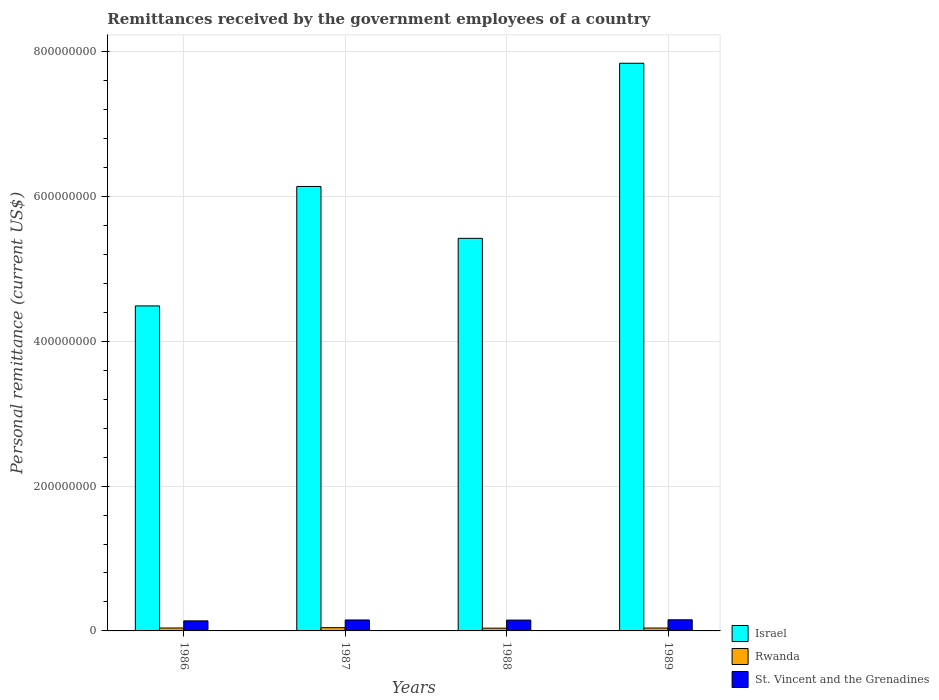Are the number of bars per tick equal to the number of legend labels?
Provide a succinct answer. Yes. Are the number of bars on each tick of the X-axis equal?
Your answer should be very brief. Yes. How many bars are there on the 1st tick from the right?
Keep it short and to the point. 3. What is the remittances received by the government employees in Israel in 1987?
Give a very brief answer. 6.14e+08. Across all years, what is the maximum remittances received by the government employees in St. Vincent and the Grenadines?
Keep it short and to the point. 1.54e+07. Across all years, what is the minimum remittances received by the government employees in St. Vincent and the Grenadines?
Make the answer very short. 1.39e+07. What is the total remittances received by the government employees in Rwanda in the graph?
Make the answer very short. 1.63e+07. What is the difference between the remittances received by the government employees in Rwanda in 1987 and that in 1989?
Keep it short and to the point. 5.25e+05. What is the difference between the remittances received by the government employees in Rwanda in 1988 and the remittances received by the government employees in St. Vincent and the Grenadines in 1987?
Offer a very short reply. -1.13e+07. What is the average remittances received by the government employees in Rwanda per year?
Provide a short and direct response. 4.07e+06. In the year 1989, what is the difference between the remittances received by the government employees in St. Vincent and the Grenadines and remittances received by the government employees in Israel?
Provide a succinct answer. -7.68e+08. What is the ratio of the remittances received by the government employees in Rwanda in 1988 to that in 1989?
Keep it short and to the point. 0.96. Is the difference between the remittances received by the government employees in St. Vincent and the Grenadines in 1987 and 1988 greater than the difference between the remittances received by the government employees in Israel in 1987 and 1988?
Offer a very short reply. No. What is the difference between the highest and the second highest remittances received by the government employees in St. Vincent and the Grenadines?
Give a very brief answer. 2.59e+05. What is the difference between the highest and the lowest remittances received by the government employees in Israel?
Give a very brief answer. 3.35e+08. What does the 2nd bar from the left in 1988 represents?
Offer a terse response. Rwanda. What does the 2nd bar from the right in 1989 represents?
Your answer should be very brief. Rwanda. How many bars are there?
Provide a short and direct response. 12. How many years are there in the graph?
Keep it short and to the point. 4. Does the graph contain any zero values?
Your response must be concise. No. Where does the legend appear in the graph?
Your answer should be very brief. Bottom right. How many legend labels are there?
Your response must be concise. 3. How are the legend labels stacked?
Ensure brevity in your answer.  Vertical. What is the title of the graph?
Provide a short and direct response. Remittances received by the government employees of a country. What is the label or title of the X-axis?
Ensure brevity in your answer.  Years. What is the label or title of the Y-axis?
Offer a very short reply. Personal remittance (current US$). What is the Personal remittance (current US$) in Israel in 1986?
Keep it short and to the point. 4.49e+08. What is the Personal remittance (current US$) in Rwanda in 1986?
Offer a very short reply. 4.02e+06. What is the Personal remittance (current US$) in St. Vincent and the Grenadines in 1986?
Give a very brief answer. 1.39e+07. What is the Personal remittance (current US$) in Israel in 1987?
Offer a very short reply. 6.14e+08. What is the Personal remittance (current US$) in Rwanda in 1987?
Give a very brief answer. 4.48e+06. What is the Personal remittance (current US$) of St. Vincent and the Grenadines in 1987?
Make the answer very short. 1.51e+07. What is the Personal remittance (current US$) in Israel in 1988?
Keep it short and to the point. 5.42e+08. What is the Personal remittance (current US$) in Rwanda in 1988?
Your answer should be very brief. 3.81e+06. What is the Personal remittance (current US$) of St. Vincent and the Grenadines in 1988?
Give a very brief answer. 1.50e+07. What is the Personal remittance (current US$) in Israel in 1989?
Provide a succinct answer. 7.84e+08. What is the Personal remittance (current US$) in Rwanda in 1989?
Keep it short and to the point. 3.96e+06. What is the Personal remittance (current US$) in St. Vincent and the Grenadines in 1989?
Give a very brief answer. 1.54e+07. Across all years, what is the maximum Personal remittance (current US$) of Israel?
Make the answer very short. 7.84e+08. Across all years, what is the maximum Personal remittance (current US$) in Rwanda?
Your answer should be very brief. 4.48e+06. Across all years, what is the maximum Personal remittance (current US$) of St. Vincent and the Grenadines?
Make the answer very short. 1.54e+07. Across all years, what is the minimum Personal remittance (current US$) of Israel?
Your response must be concise. 4.49e+08. Across all years, what is the minimum Personal remittance (current US$) of Rwanda?
Your answer should be compact. 3.81e+06. Across all years, what is the minimum Personal remittance (current US$) of St. Vincent and the Grenadines?
Your answer should be very brief. 1.39e+07. What is the total Personal remittance (current US$) of Israel in the graph?
Make the answer very short. 2.39e+09. What is the total Personal remittance (current US$) of Rwanda in the graph?
Make the answer very short. 1.63e+07. What is the total Personal remittance (current US$) of St. Vincent and the Grenadines in the graph?
Ensure brevity in your answer.  5.93e+07. What is the difference between the Personal remittance (current US$) of Israel in 1986 and that in 1987?
Give a very brief answer. -1.65e+08. What is the difference between the Personal remittance (current US$) in Rwanda in 1986 and that in 1987?
Give a very brief answer. -4.62e+05. What is the difference between the Personal remittance (current US$) of St. Vincent and the Grenadines in 1986 and that in 1987?
Provide a succinct answer. -1.22e+06. What is the difference between the Personal remittance (current US$) in Israel in 1986 and that in 1988?
Give a very brief answer. -9.33e+07. What is the difference between the Personal remittance (current US$) in Rwanda in 1986 and that in 1988?
Offer a terse response. 2.12e+05. What is the difference between the Personal remittance (current US$) in St. Vincent and the Grenadines in 1986 and that in 1988?
Your answer should be compact. -1.07e+06. What is the difference between the Personal remittance (current US$) of Israel in 1986 and that in 1989?
Make the answer very short. -3.35e+08. What is the difference between the Personal remittance (current US$) of Rwanda in 1986 and that in 1989?
Make the answer very short. 6.35e+04. What is the difference between the Personal remittance (current US$) of St. Vincent and the Grenadines in 1986 and that in 1989?
Offer a very short reply. -1.48e+06. What is the difference between the Personal remittance (current US$) of Israel in 1987 and that in 1988?
Keep it short and to the point. 7.16e+07. What is the difference between the Personal remittance (current US$) of Rwanda in 1987 and that in 1988?
Offer a very short reply. 6.74e+05. What is the difference between the Personal remittance (current US$) of St. Vincent and the Grenadines in 1987 and that in 1988?
Your answer should be very brief. 1.48e+05. What is the difference between the Personal remittance (current US$) of Israel in 1987 and that in 1989?
Make the answer very short. -1.70e+08. What is the difference between the Personal remittance (current US$) in Rwanda in 1987 and that in 1989?
Provide a short and direct response. 5.25e+05. What is the difference between the Personal remittance (current US$) of St. Vincent and the Grenadines in 1987 and that in 1989?
Ensure brevity in your answer.  -2.59e+05. What is the difference between the Personal remittance (current US$) in Israel in 1988 and that in 1989?
Your response must be concise. -2.42e+08. What is the difference between the Personal remittance (current US$) in Rwanda in 1988 and that in 1989?
Your response must be concise. -1.49e+05. What is the difference between the Personal remittance (current US$) of St. Vincent and the Grenadines in 1988 and that in 1989?
Provide a short and direct response. -4.07e+05. What is the difference between the Personal remittance (current US$) in Israel in 1986 and the Personal remittance (current US$) in Rwanda in 1987?
Provide a succinct answer. 4.44e+08. What is the difference between the Personal remittance (current US$) of Israel in 1986 and the Personal remittance (current US$) of St. Vincent and the Grenadines in 1987?
Make the answer very short. 4.34e+08. What is the difference between the Personal remittance (current US$) in Rwanda in 1986 and the Personal remittance (current US$) in St. Vincent and the Grenadines in 1987?
Provide a short and direct response. -1.11e+07. What is the difference between the Personal remittance (current US$) of Israel in 1986 and the Personal remittance (current US$) of Rwanda in 1988?
Provide a succinct answer. 4.45e+08. What is the difference between the Personal remittance (current US$) of Israel in 1986 and the Personal remittance (current US$) of St. Vincent and the Grenadines in 1988?
Provide a succinct answer. 4.34e+08. What is the difference between the Personal remittance (current US$) in Rwanda in 1986 and the Personal remittance (current US$) in St. Vincent and the Grenadines in 1988?
Offer a terse response. -1.09e+07. What is the difference between the Personal remittance (current US$) in Israel in 1986 and the Personal remittance (current US$) in Rwanda in 1989?
Your answer should be very brief. 4.45e+08. What is the difference between the Personal remittance (current US$) of Israel in 1986 and the Personal remittance (current US$) of St. Vincent and the Grenadines in 1989?
Make the answer very short. 4.33e+08. What is the difference between the Personal remittance (current US$) of Rwanda in 1986 and the Personal remittance (current US$) of St. Vincent and the Grenadines in 1989?
Provide a succinct answer. -1.14e+07. What is the difference between the Personal remittance (current US$) in Israel in 1987 and the Personal remittance (current US$) in Rwanda in 1988?
Your answer should be compact. 6.10e+08. What is the difference between the Personal remittance (current US$) of Israel in 1987 and the Personal remittance (current US$) of St. Vincent and the Grenadines in 1988?
Ensure brevity in your answer.  5.99e+08. What is the difference between the Personal remittance (current US$) in Rwanda in 1987 and the Personal remittance (current US$) in St. Vincent and the Grenadines in 1988?
Your response must be concise. -1.05e+07. What is the difference between the Personal remittance (current US$) in Israel in 1987 and the Personal remittance (current US$) in Rwanda in 1989?
Make the answer very short. 6.10e+08. What is the difference between the Personal remittance (current US$) in Israel in 1987 and the Personal remittance (current US$) in St. Vincent and the Grenadines in 1989?
Your answer should be compact. 5.98e+08. What is the difference between the Personal remittance (current US$) of Rwanda in 1987 and the Personal remittance (current US$) of St. Vincent and the Grenadines in 1989?
Keep it short and to the point. -1.09e+07. What is the difference between the Personal remittance (current US$) of Israel in 1988 and the Personal remittance (current US$) of Rwanda in 1989?
Keep it short and to the point. 5.38e+08. What is the difference between the Personal remittance (current US$) of Israel in 1988 and the Personal remittance (current US$) of St. Vincent and the Grenadines in 1989?
Offer a very short reply. 5.27e+08. What is the difference between the Personal remittance (current US$) in Rwanda in 1988 and the Personal remittance (current US$) in St. Vincent and the Grenadines in 1989?
Provide a short and direct response. -1.16e+07. What is the average Personal remittance (current US$) of Israel per year?
Provide a succinct answer. 5.97e+08. What is the average Personal remittance (current US$) of Rwanda per year?
Provide a short and direct response. 4.07e+06. What is the average Personal remittance (current US$) of St. Vincent and the Grenadines per year?
Your answer should be compact. 1.48e+07. In the year 1986, what is the difference between the Personal remittance (current US$) in Israel and Personal remittance (current US$) in Rwanda?
Your response must be concise. 4.45e+08. In the year 1986, what is the difference between the Personal remittance (current US$) in Israel and Personal remittance (current US$) in St. Vincent and the Grenadines?
Your answer should be very brief. 4.35e+08. In the year 1986, what is the difference between the Personal remittance (current US$) of Rwanda and Personal remittance (current US$) of St. Vincent and the Grenadines?
Offer a very short reply. -9.87e+06. In the year 1987, what is the difference between the Personal remittance (current US$) of Israel and Personal remittance (current US$) of Rwanda?
Give a very brief answer. 6.09e+08. In the year 1987, what is the difference between the Personal remittance (current US$) of Israel and Personal remittance (current US$) of St. Vincent and the Grenadines?
Provide a succinct answer. 5.98e+08. In the year 1987, what is the difference between the Personal remittance (current US$) of Rwanda and Personal remittance (current US$) of St. Vincent and the Grenadines?
Your response must be concise. -1.06e+07. In the year 1988, what is the difference between the Personal remittance (current US$) in Israel and Personal remittance (current US$) in Rwanda?
Offer a very short reply. 5.38e+08. In the year 1988, what is the difference between the Personal remittance (current US$) of Israel and Personal remittance (current US$) of St. Vincent and the Grenadines?
Your answer should be compact. 5.27e+08. In the year 1988, what is the difference between the Personal remittance (current US$) of Rwanda and Personal remittance (current US$) of St. Vincent and the Grenadines?
Ensure brevity in your answer.  -1.12e+07. In the year 1989, what is the difference between the Personal remittance (current US$) of Israel and Personal remittance (current US$) of Rwanda?
Keep it short and to the point. 7.80e+08. In the year 1989, what is the difference between the Personal remittance (current US$) of Israel and Personal remittance (current US$) of St. Vincent and the Grenadines?
Make the answer very short. 7.68e+08. In the year 1989, what is the difference between the Personal remittance (current US$) of Rwanda and Personal remittance (current US$) of St. Vincent and the Grenadines?
Provide a succinct answer. -1.14e+07. What is the ratio of the Personal remittance (current US$) of Israel in 1986 to that in 1987?
Your answer should be very brief. 0.73. What is the ratio of the Personal remittance (current US$) in Rwanda in 1986 to that in 1987?
Offer a terse response. 0.9. What is the ratio of the Personal remittance (current US$) of St. Vincent and the Grenadines in 1986 to that in 1987?
Provide a succinct answer. 0.92. What is the ratio of the Personal remittance (current US$) of Israel in 1986 to that in 1988?
Your response must be concise. 0.83. What is the ratio of the Personal remittance (current US$) in Rwanda in 1986 to that in 1988?
Your response must be concise. 1.06. What is the ratio of the Personal remittance (current US$) of St. Vincent and the Grenadines in 1986 to that in 1988?
Make the answer very short. 0.93. What is the ratio of the Personal remittance (current US$) in Israel in 1986 to that in 1989?
Your answer should be compact. 0.57. What is the ratio of the Personal remittance (current US$) of Rwanda in 1986 to that in 1989?
Offer a terse response. 1.02. What is the ratio of the Personal remittance (current US$) of St. Vincent and the Grenadines in 1986 to that in 1989?
Provide a succinct answer. 0.9. What is the ratio of the Personal remittance (current US$) in Israel in 1987 to that in 1988?
Make the answer very short. 1.13. What is the ratio of the Personal remittance (current US$) in Rwanda in 1987 to that in 1988?
Offer a terse response. 1.18. What is the ratio of the Personal remittance (current US$) in St. Vincent and the Grenadines in 1987 to that in 1988?
Provide a short and direct response. 1.01. What is the ratio of the Personal remittance (current US$) in Israel in 1987 to that in 1989?
Give a very brief answer. 0.78. What is the ratio of the Personal remittance (current US$) of Rwanda in 1987 to that in 1989?
Keep it short and to the point. 1.13. What is the ratio of the Personal remittance (current US$) of St. Vincent and the Grenadines in 1987 to that in 1989?
Provide a short and direct response. 0.98. What is the ratio of the Personal remittance (current US$) in Israel in 1988 to that in 1989?
Make the answer very short. 0.69. What is the ratio of the Personal remittance (current US$) in Rwanda in 1988 to that in 1989?
Provide a short and direct response. 0.96. What is the ratio of the Personal remittance (current US$) of St. Vincent and the Grenadines in 1988 to that in 1989?
Your answer should be compact. 0.97. What is the difference between the highest and the second highest Personal remittance (current US$) in Israel?
Provide a short and direct response. 1.70e+08. What is the difference between the highest and the second highest Personal remittance (current US$) of Rwanda?
Make the answer very short. 4.62e+05. What is the difference between the highest and the second highest Personal remittance (current US$) in St. Vincent and the Grenadines?
Your answer should be compact. 2.59e+05. What is the difference between the highest and the lowest Personal remittance (current US$) of Israel?
Your response must be concise. 3.35e+08. What is the difference between the highest and the lowest Personal remittance (current US$) in Rwanda?
Provide a succinct answer. 6.74e+05. What is the difference between the highest and the lowest Personal remittance (current US$) of St. Vincent and the Grenadines?
Offer a terse response. 1.48e+06. 